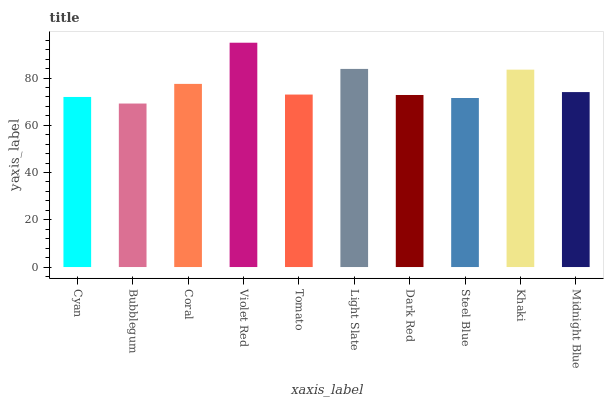Is Coral the minimum?
Answer yes or no. No. Is Coral the maximum?
Answer yes or no. No. Is Coral greater than Bubblegum?
Answer yes or no. Yes. Is Bubblegum less than Coral?
Answer yes or no. Yes. Is Bubblegum greater than Coral?
Answer yes or no. No. Is Coral less than Bubblegum?
Answer yes or no. No. Is Midnight Blue the high median?
Answer yes or no. Yes. Is Tomato the low median?
Answer yes or no. Yes. Is Coral the high median?
Answer yes or no. No. Is Violet Red the low median?
Answer yes or no. No. 